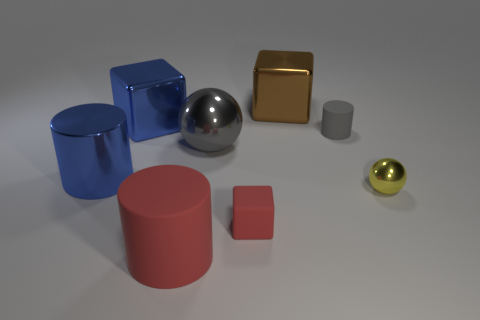Add 1 tiny metal spheres. How many objects exist? 9 Subtract all gray cylinders. How many cylinders are left? 2 Subtract all big cylinders. How many cylinders are left? 1 Subtract all purple blocks. Subtract all brown cylinders. How many blocks are left? 3 Subtract all yellow cylinders. How many gray spheres are left? 1 Subtract all big green matte cubes. Subtract all big blue metallic cubes. How many objects are left? 7 Add 4 metallic cylinders. How many metallic cylinders are left? 5 Add 5 gray matte cubes. How many gray matte cubes exist? 5 Subtract 0 cyan cylinders. How many objects are left? 8 Subtract all balls. How many objects are left? 6 